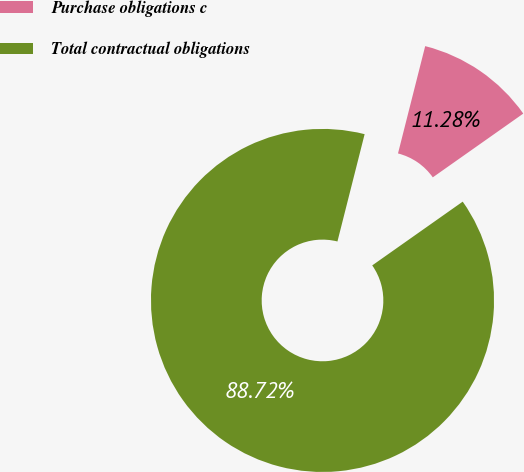Convert chart to OTSL. <chart><loc_0><loc_0><loc_500><loc_500><pie_chart><fcel>Purchase obligations c<fcel>Total contractual obligations<nl><fcel>11.28%<fcel>88.72%<nl></chart> 